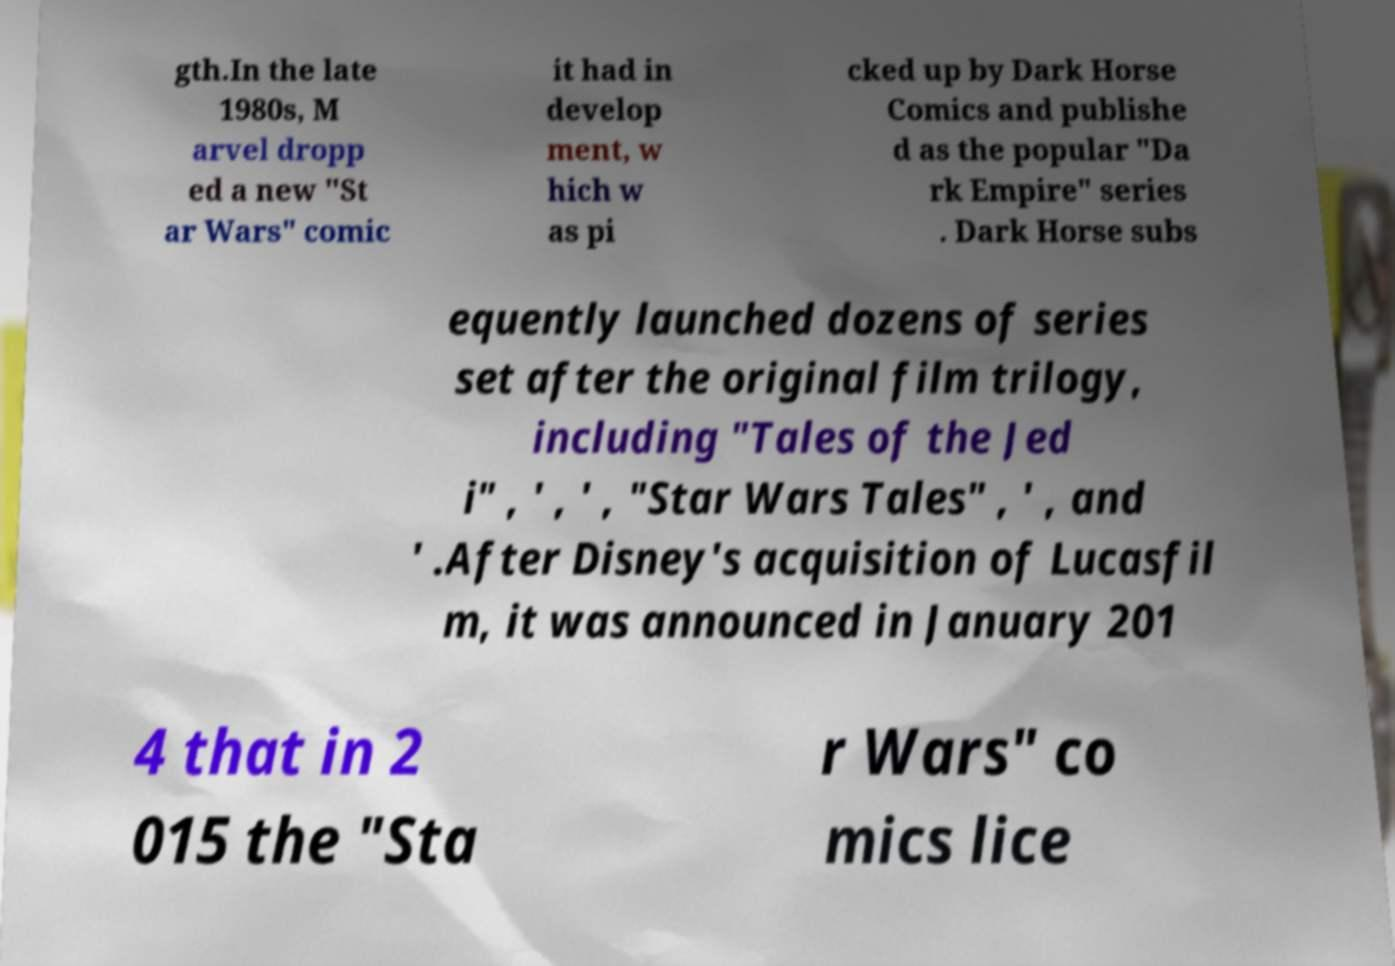Please read and relay the text visible in this image. What does it say? gth.In the late 1980s, M arvel dropp ed a new "St ar Wars" comic it had in develop ment, w hich w as pi cked up by Dark Horse Comics and publishe d as the popular "Da rk Empire" series . Dark Horse subs equently launched dozens of series set after the original film trilogy, including "Tales of the Jed i" , ' , ' , "Star Wars Tales" , ' , and ' .After Disney's acquisition of Lucasfil m, it was announced in January 201 4 that in 2 015 the "Sta r Wars" co mics lice 